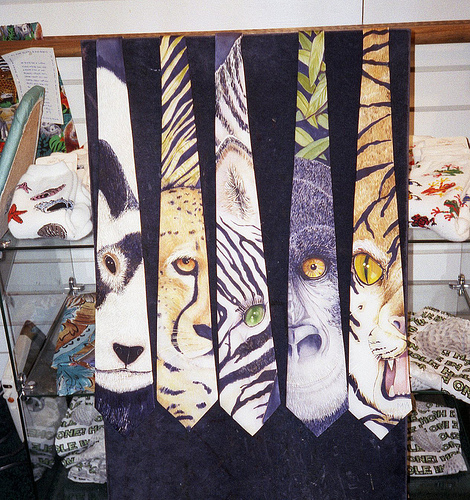What occasion might these ties be suitable for? These animal-themed ties could add a playful and creative touch to various occasions, particularly events that celebrate wildlife, art exhibitions, or informal social gatherings where such unique accessories could spark conversation. 